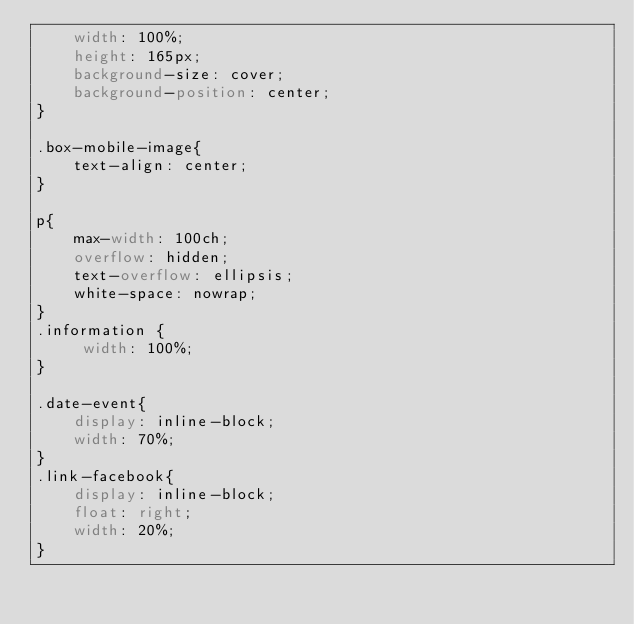Convert code to text. <code><loc_0><loc_0><loc_500><loc_500><_CSS_>    width: 100%;
    height: 165px;
    background-size: cover;
    background-position: center;
}

.box-mobile-image{
    text-align: center;
}

p{
    max-width: 100ch;
    overflow: hidden;
    text-overflow: ellipsis;
    white-space: nowrap;
}
.information {
     width: 100%;
}

.date-event{
    display: inline-block;
    width: 70%;
}
.link-facebook{
    display: inline-block;
    float: right;
    width: 20%;
}</code> 